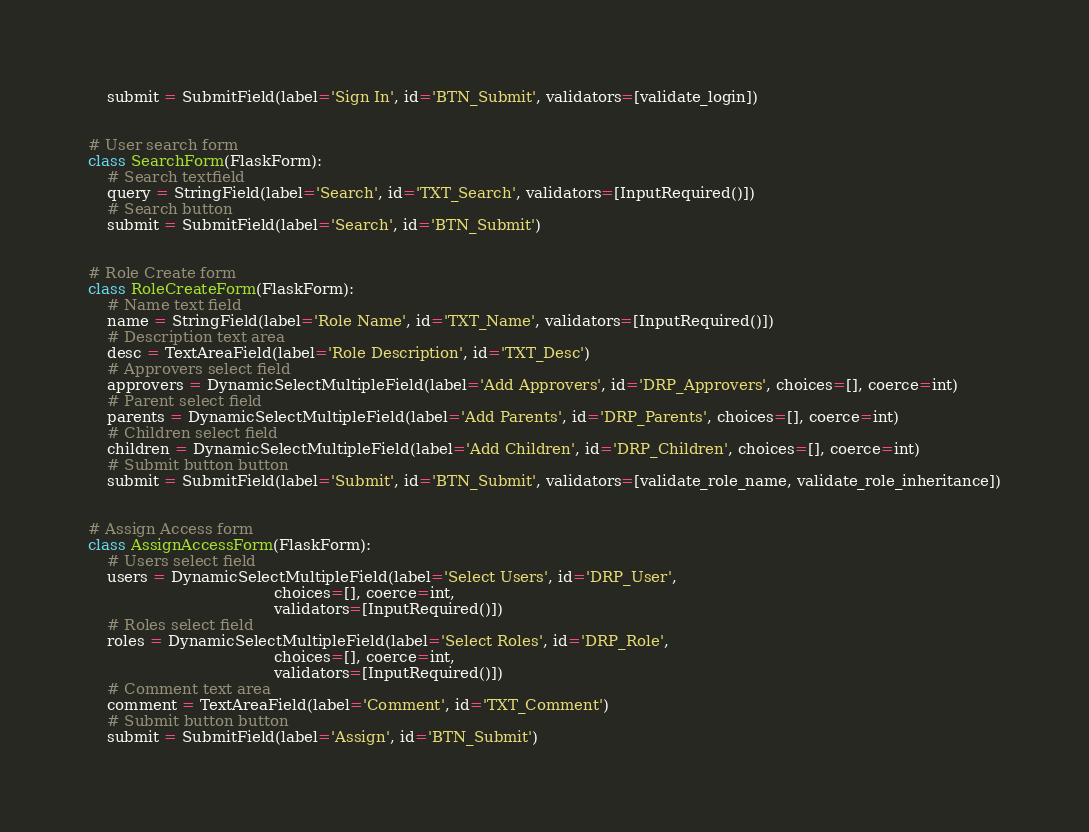<code> <loc_0><loc_0><loc_500><loc_500><_Python_>    submit = SubmitField(label='Sign In', id='BTN_Submit', validators=[validate_login])


# User search form
class SearchForm(FlaskForm):
    # Search textfield
    query = StringField(label='Search', id='TXT_Search', validators=[InputRequired()])
    # Search button
    submit = SubmitField(label='Search', id='BTN_Submit')


# Role Create form
class RoleCreateForm(FlaskForm):
    # Name text field
    name = StringField(label='Role Name', id='TXT_Name', validators=[InputRequired()])
    # Description text area
    desc = TextAreaField(label='Role Description', id='TXT_Desc')
    # Approvers select field
    approvers = DynamicSelectMultipleField(label='Add Approvers', id='DRP_Approvers', choices=[], coerce=int)
    # Parent select field
    parents = DynamicSelectMultipleField(label='Add Parents', id='DRP_Parents', choices=[], coerce=int)
    # Children select field
    children = DynamicSelectMultipleField(label='Add Children', id='DRP_Children', choices=[], coerce=int)
    # Submit button button
    submit = SubmitField(label='Submit', id='BTN_Submit', validators=[validate_role_name, validate_role_inheritance])


# Assign Access form
class AssignAccessForm(FlaskForm):
    # Users select field
    users = DynamicSelectMultipleField(label='Select Users', id='DRP_User',
                                       choices=[], coerce=int,
                                       validators=[InputRequired()])
    # Roles select field
    roles = DynamicSelectMultipleField(label='Select Roles', id='DRP_Role',
                                       choices=[], coerce=int,
                                       validators=[InputRequired()])
    # Comment text area
    comment = TextAreaField(label='Comment', id='TXT_Comment')
    # Submit button button
    submit = SubmitField(label='Assign', id='BTN_Submit')
</code> 